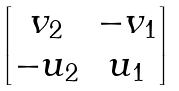<formula> <loc_0><loc_0><loc_500><loc_500>\begin{bmatrix} v _ { 2 } & - v _ { 1 } \\ - u _ { 2 } & u _ { 1 } \end{bmatrix}</formula> 